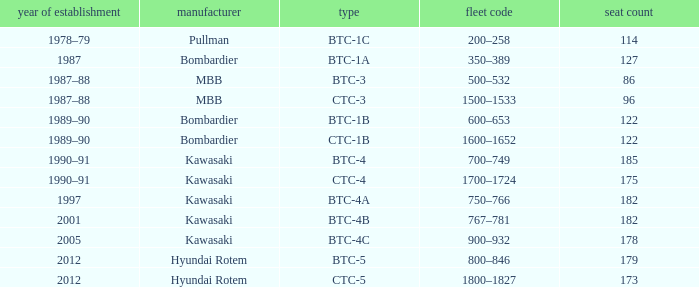How many seats does the BTC-5 model have? 179.0. 